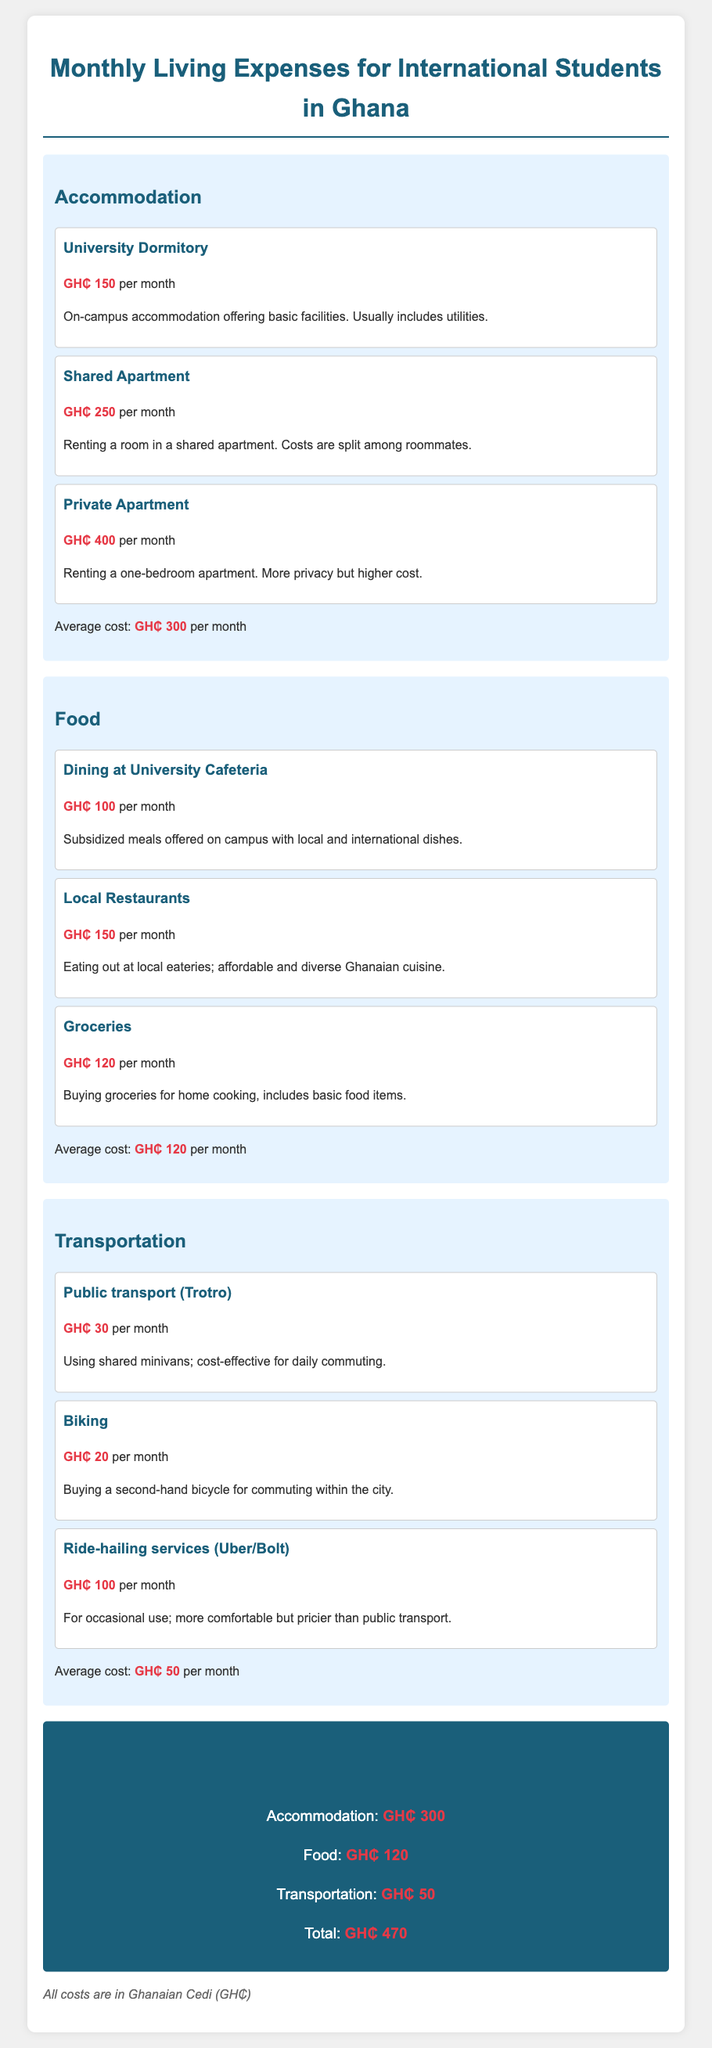What is the average cost of accommodation? The average cost of accommodation is found in the accommodation section, which mentions GH₵ 300 per month.
Answer: GH₵ 300 How much does a shared apartment cost? It is listed under the accommodation category, specified to cost GH₵ 250 per month.
Answer: GH₵ 250 What is the total estimated monthly cost for an international student? The total cost is summarized at the end of the document, which states GH₵ 470.
Answer: GH₵ 470 How much do public transport (Trotro) costs? This cost is detailed in the transportation section, where it is indicated to be GH₵ 30 per month.
Answer: GH₵ 30 What is the average cost of food? The document states the average cost of food is GH₵ 120 per month, found in the food section.
Answer: GH₵ 120 What accommodation option offers the lowest cost? The university dormitory is mentioned as the least expensive option, priced at GH₵ 150 per month.
Answer: GH₵ 150 How much is the cost for dining at the university cafeteria? It is specified in the food section that dining costs GH₵ 100 per month.
Answer: GH₵ 100 Which transportation option is the most expensive? The ride-hailing services (Uber/Bolt) are indicated as the most expensive, costing GH₵ 100 per month.
Answer: GH₵ 100 What is the cost of groceries? The groceries cost is mentioned in the food section as GH₵ 120 per month.
Answer: GH₵ 120 